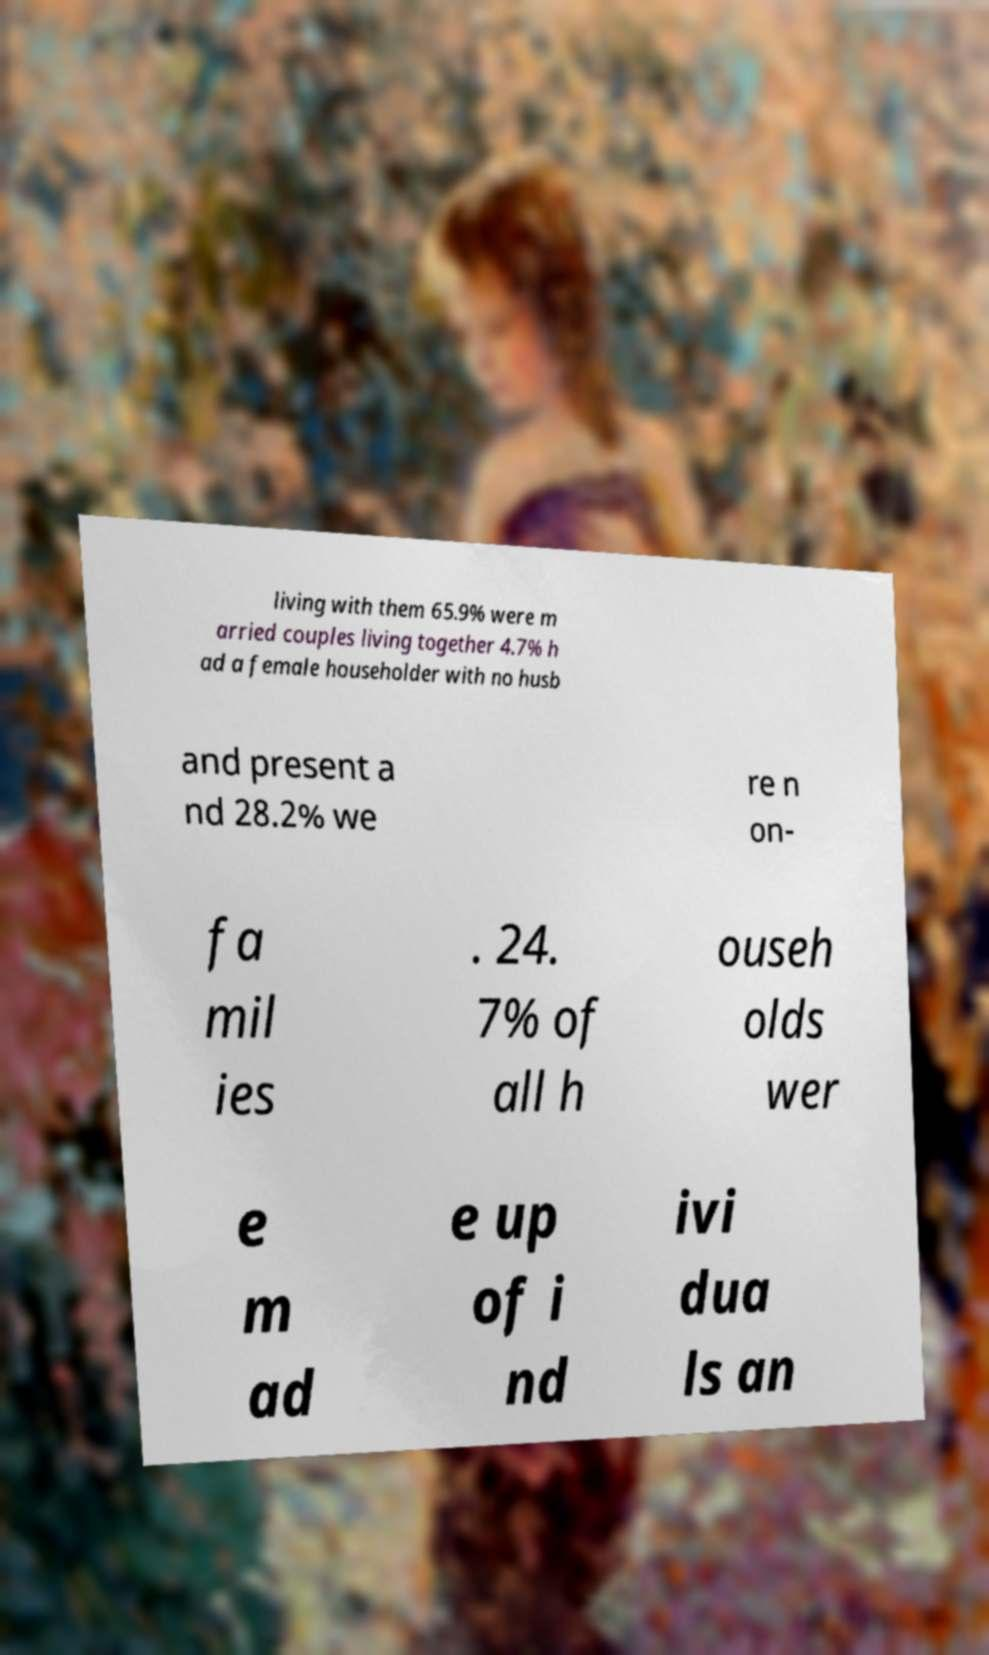I need the written content from this picture converted into text. Can you do that? living with them 65.9% were m arried couples living together 4.7% h ad a female householder with no husb and present a nd 28.2% we re n on- fa mil ies . 24. 7% of all h ouseh olds wer e m ad e up of i nd ivi dua ls an 